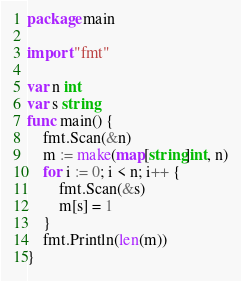<code> <loc_0><loc_0><loc_500><loc_500><_Go_>package main
 
import "fmt"
 
var n int
var s string
func main() {
	fmt.Scan(&n)
	m := make(map[string]int, n)
	for i := 0; i < n; i++ {
		fmt.Scan(&s)
		m[s] = 1
	}
	fmt.Println(len(m))
}</code> 